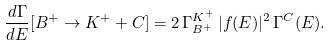<formula> <loc_0><loc_0><loc_500><loc_500>\frac { d \Gamma } { d E } [ B ^ { + } \to K ^ { + } + C ] = 2 \, \Gamma _ { B ^ { + } } ^ { K ^ { + } } \, | f ( E ) | ^ { 2 } \, \Gamma ^ { C } ( E ) .</formula> 